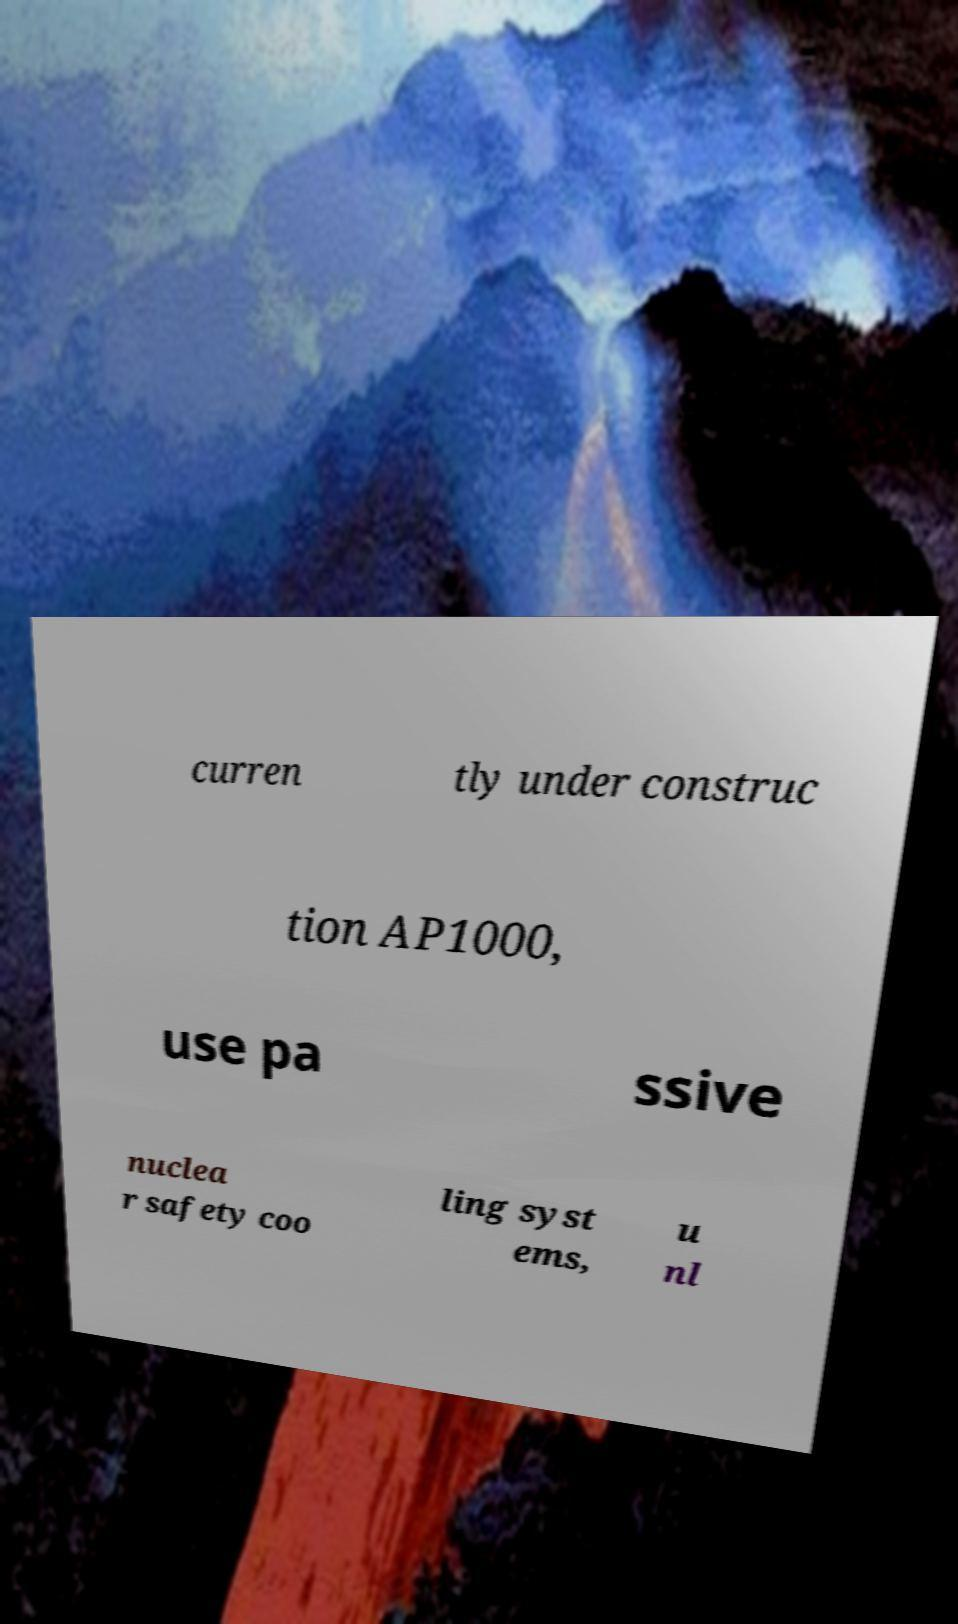Could you extract and type out the text from this image? curren tly under construc tion AP1000, use pa ssive nuclea r safety coo ling syst ems, u nl 